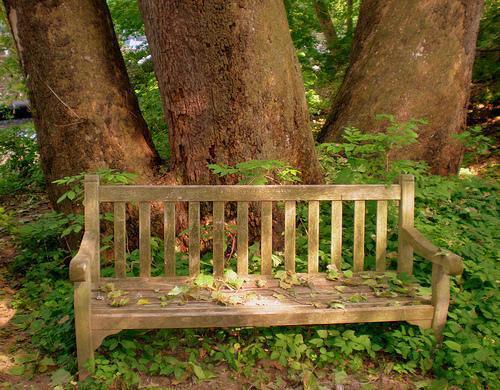How many trees are shown?
Give a very brief answer. 3. 